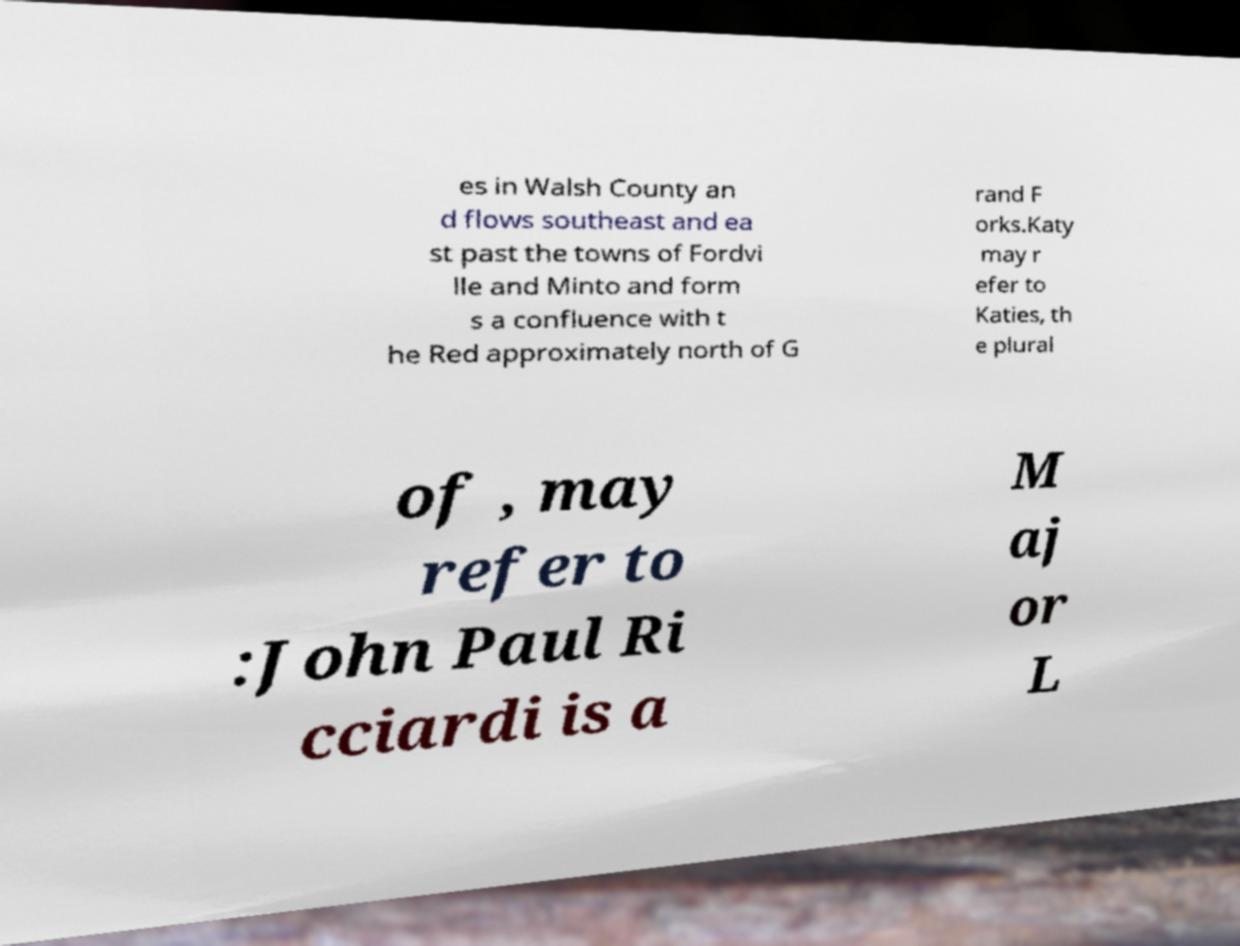Could you assist in decoding the text presented in this image and type it out clearly? es in Walsh County an d flows southeast and ea st past the towns of Fordvi lle and Minto and form s a confluence with t he Red approximately north of G rand F orks.Katy may r efer to Katies, th e plural of , may refer to :John Paul Ri cciardi is a M aj or L 